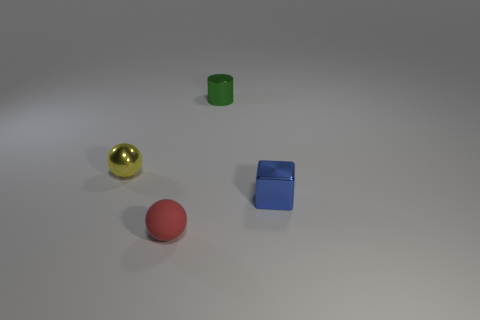Add 3 tiny objects. How many objects exist? 7 Subtract all cubes. How many objects are left? 3 Add 3 tiny cylinders. How many tiny cylinders exist? 4 Subtract 0 yellow cubes. How many objects are left? 4 Subtract all big yellow cylinders. Subtract all yellow metal spheres. How many objects are left? 3 Add 3 yellow things. How many yellow things are left? 4 